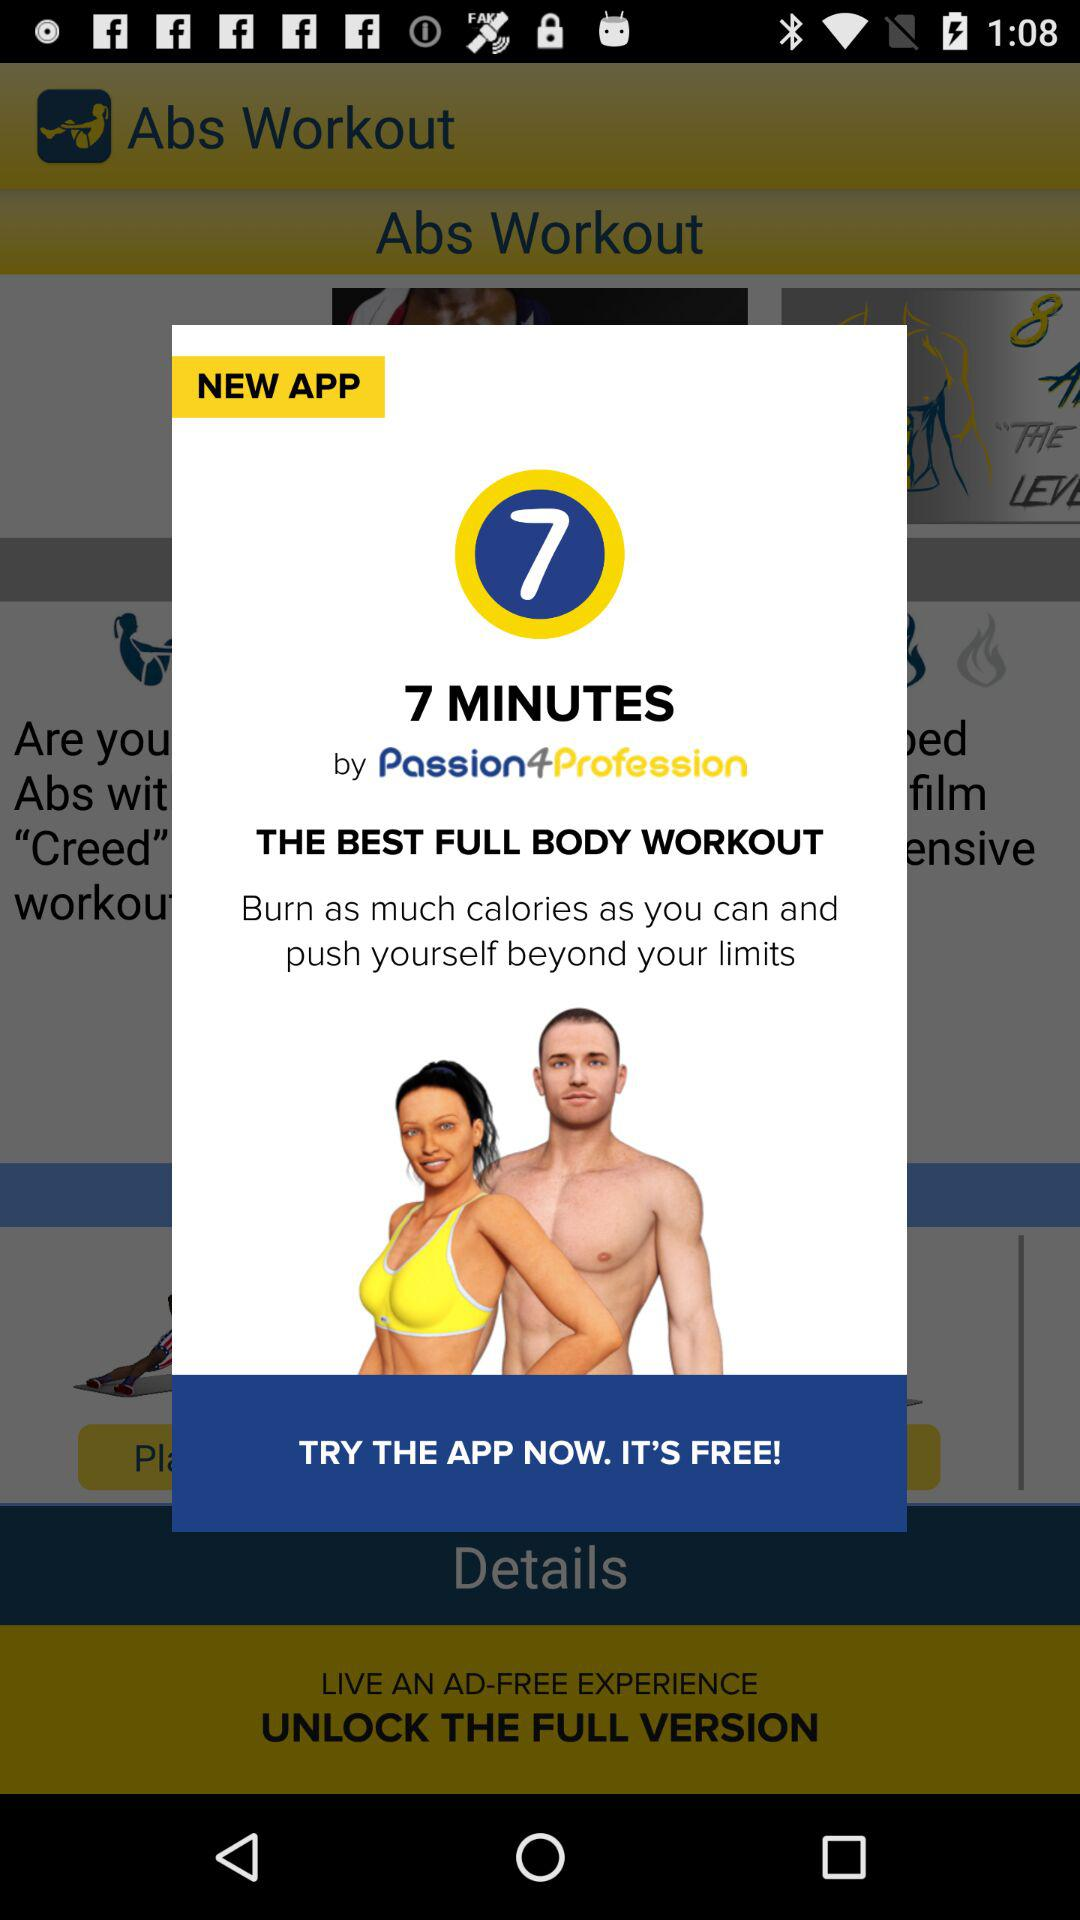How many minutes are shown on the screen?
When the provided information is insufficient, respond with <no answer>. <no answer> 